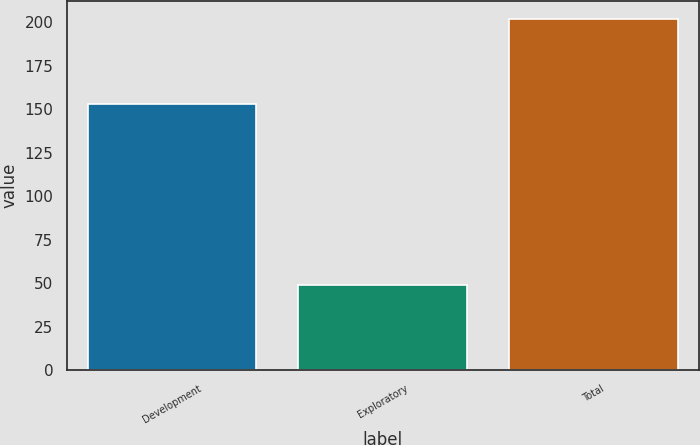Convert chart. <chart><loc_0><loc_0><loc_500><loc_500><bar_chart><fcel>Development<fcel>Exploratory<fcel>Total<nl><fcel>153<fcel>49<fcel>202<nl></chart> 